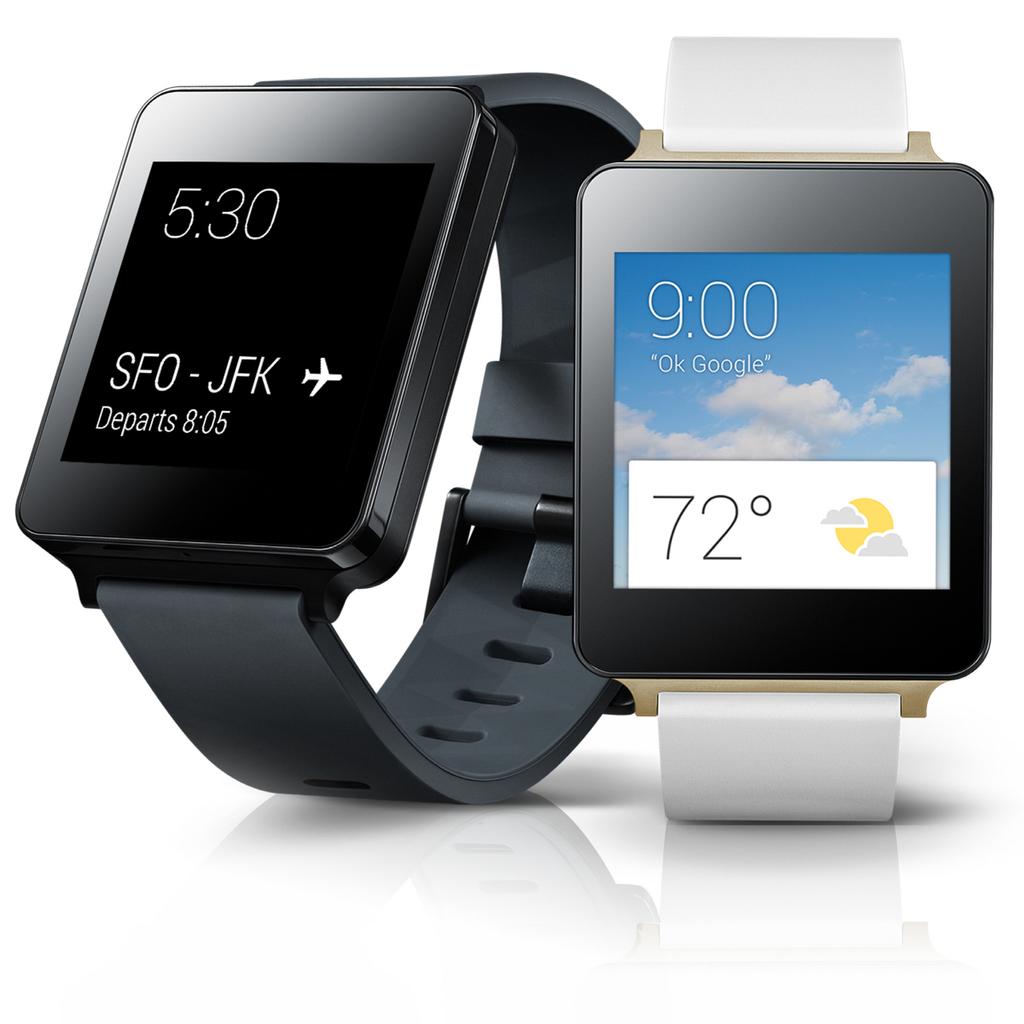What airport is mentioned on the watch?
Provide a succinct answer. Jfk. 